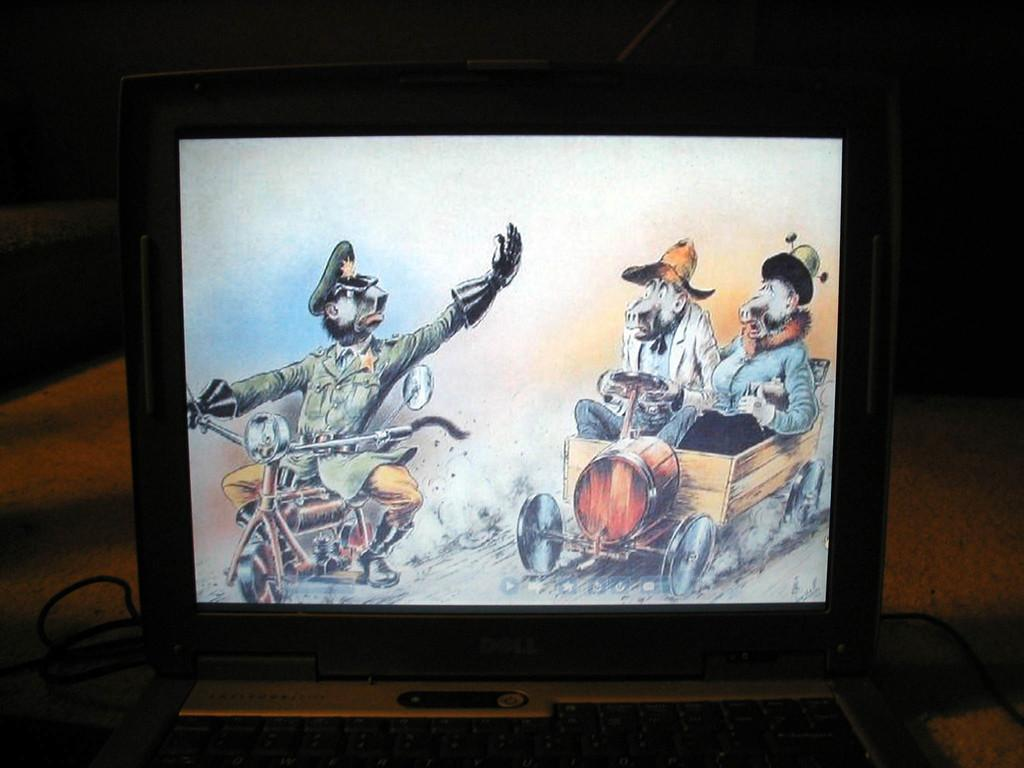<image>
Describe the image concisely. The Dell laptop has a cartoon showing on the screen. 